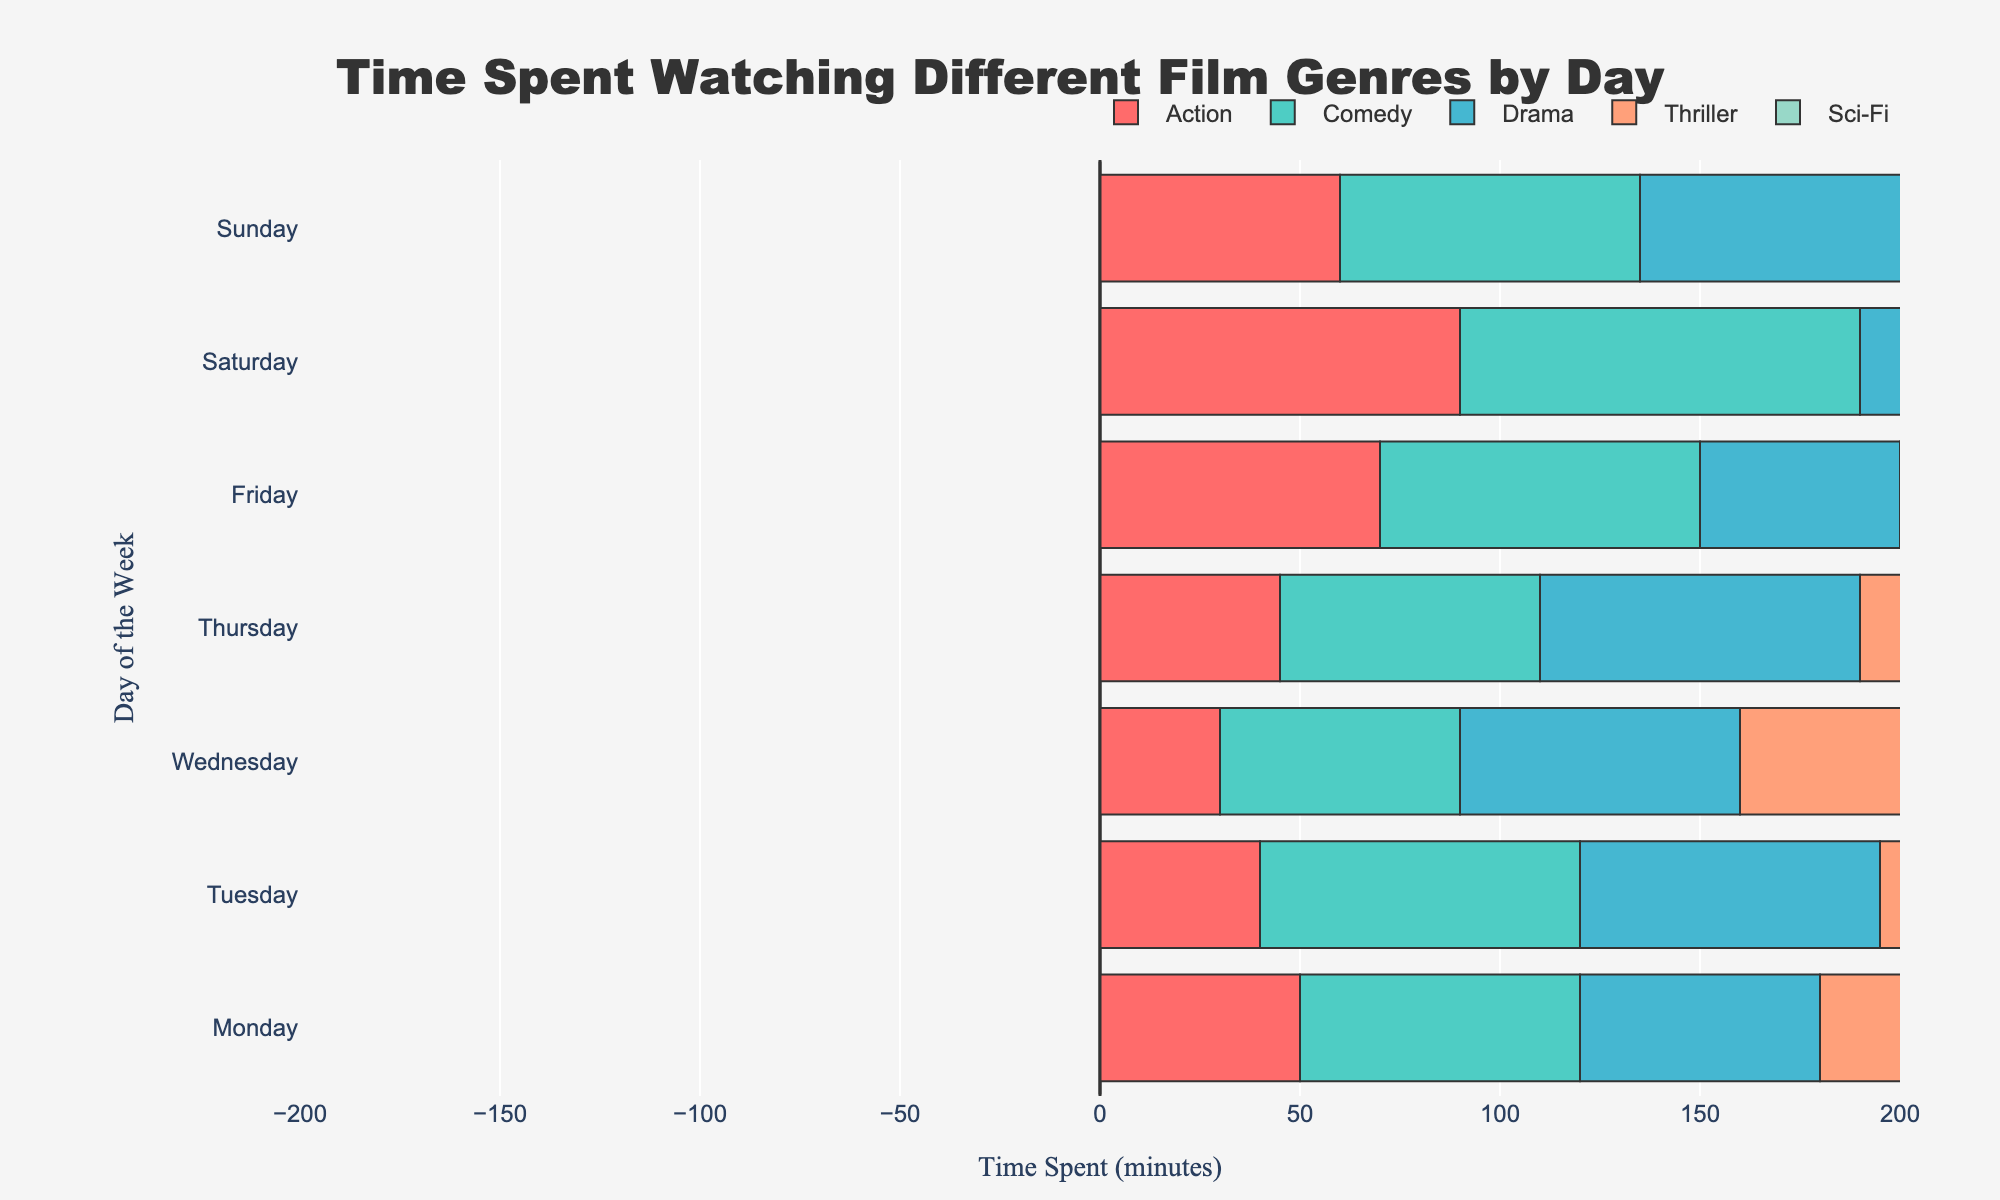What is the total time spent watching drama on Wednesdays and Thursdays? On the figure, look for the 'Drama' section on 'Wednesday' and 'Thursday'. Add the corresponding times together: Wednesday (70 minutes) + Thursday (80 minutes) = 150 minutes.
Answer: 150 minutes What genre is watched the most on Saturdays? Find the bar corresponding to 'Saturday' and identify the genre with the longest bar. The longest bar on Saturday corresponds to 'Comedy'.
Answer: Comedy Which day of the week has the least time spent watching Sci-Fi? Compare the length of the 'Sci-Fi' bars for all days. The shortest bar is on Tuesday.
Answer: Tuesday How does the time spent watching Action movies on Friday compare to that on Monday? Compare the 'Action' bars for 'Friday' and 'Monday'. The bar on Friday is longer (70 minutes) than the bar on Monday (50 minutes).
Answer: More on Friday Which genre has the most consistent viewing time across the week? Assess the length variability for bars corresponding to each genre across all days. 'Sci-Fi' shows relatively consistent lengths throughout the week.
Answer: Sci-Fi What is the difference in minutes spent watching Thrillers between Friday and Sunday? Locate the 'Thriller' bars for 'Friday' and 'Sunday'. Find the difference: Friday (60 minutes) - Sunday (60 minutes) = 0 minutes.
Answer: 0 minutes What's the most popular genre on Mondays and how much time is spent watching it? On the figure, identify the longest bar on 'Monday'. The longest bar refers to 'Comedy' with 70 minutes.
Answer: Comedy, 70 minutes Which day has the highest total time spent watching movies? Sum the lengths of all genre bars for each day. The day with the highest total is 'Saturday'.
Answer: Saturday What is the average time spent watching dramas over the entire week? Add the total minutes spent on 'Drama' for each day: 60 + 75 + 70 + 80 + 50 + 80 + 85 = 500 minutes. Divide by 7 days: 500 / 7 ≈ 71.43 minutes.
Answer: 71.43 minutes Which genre saw the biggest increase in viewing time from Monday to Saturday? Compare the lengths of bars for each genre on 'Monday' and 'Saturday' and calculate the differences. Drama increased from 60 minutes on Monday to 80 minutes on Saturday, an increase of 20 minutes.
Answer: Drama 